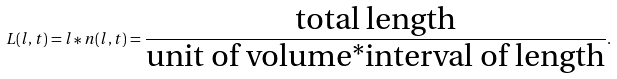<formula> <loc_0><loc_0><loc_500><loc_500>L ( l , t ) = l \ast n ( l , t ) = \frac { \text {total length} } { \text {unit of volume*interval of length} } .</formula> 